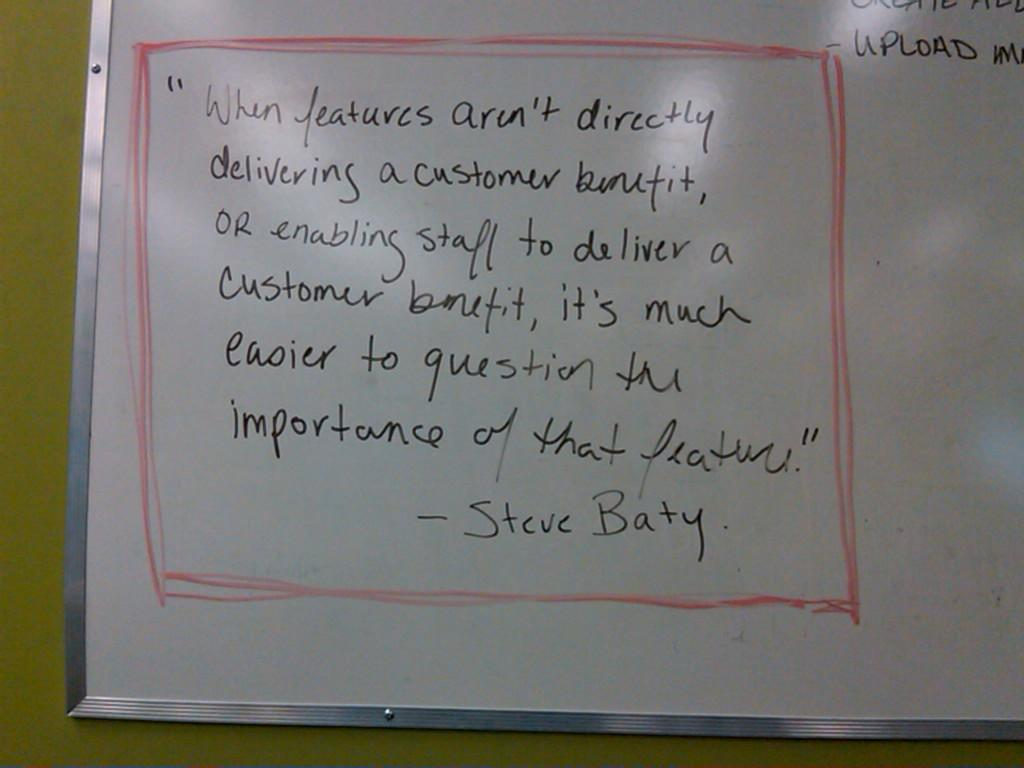Provide a one-sentence caption for the provided image. A white board features a quote by Steve Baty. 